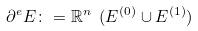<formula> <loc_0><loc_0><loc_500><loc_500>\partial ^ { e } E \colon = \mathbb { R } ^ { n } \ ( E ^ { ( 0 ) } \cup E ^ { ( 1 ) } )</formula> 